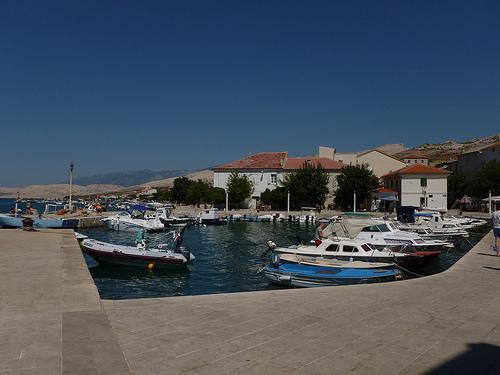How many boats are there?
Give a very brief answer. 9. 